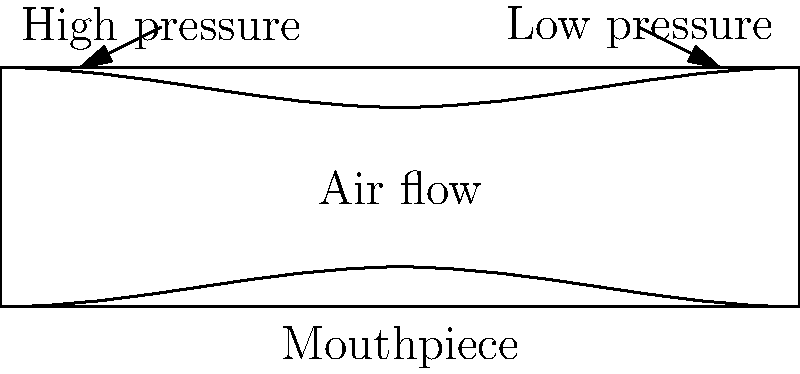In a saxophone mouthpiece, how does the shape of the interior affect the airflow and pressure distribution, and how might this relate to Louis Armstrong's distinctive sound? To understand the airflow and pressure distribution in a saxophone mouthpiece, let's break it down step-by-step:

1. Mouthpiece shape: The saxophone mouthpiece typically has a gradually narrowing interior from the tip to the bore.

2. Bernoulli's principle: As air flows through a constriction, its velocity increases and its pressure decreases.

3. Airflow pattern:
   a. Air enters the wide opening at the tip of the mouthpiece.
   b. As it moves through the narrowing passage, its velocity increases.

4. Pressure distribution:
   a. Higher pressure at the entrance of the mouthpiece.
   b. Lower pressure towards the narrow end (bore) of the mouthpiece.

5. Reed vibration: The pressure difference causes the reed to vibrate, producing sound.

6. Sound characteristics:
   a. The specific shape of the mouthpiece interior affects the airflow and pressure distribution.
   b. This, in turn, influences the reed vibration and the resulting tone.

7. Armstrong's sound: While primarily a trumpet player, Armstrong's occasional saxophone performances would have been influenced by these principles. His powerful breath control and embouchure would interact with the mouthpiece dynamics to produce his characteristic rich, warm tone.

8. Customization: Professional musicians like Armstrong often customize their mouthpieces to achieve their desired sound, which can involve subtle changes to the interior shape to alter the airflow and pressure distribution.
Answer: The narrowing shape creates a pressure gradient, with higher pressure at the entrance and lower pressure at the bore, influencing reed vibration and tone quality. 